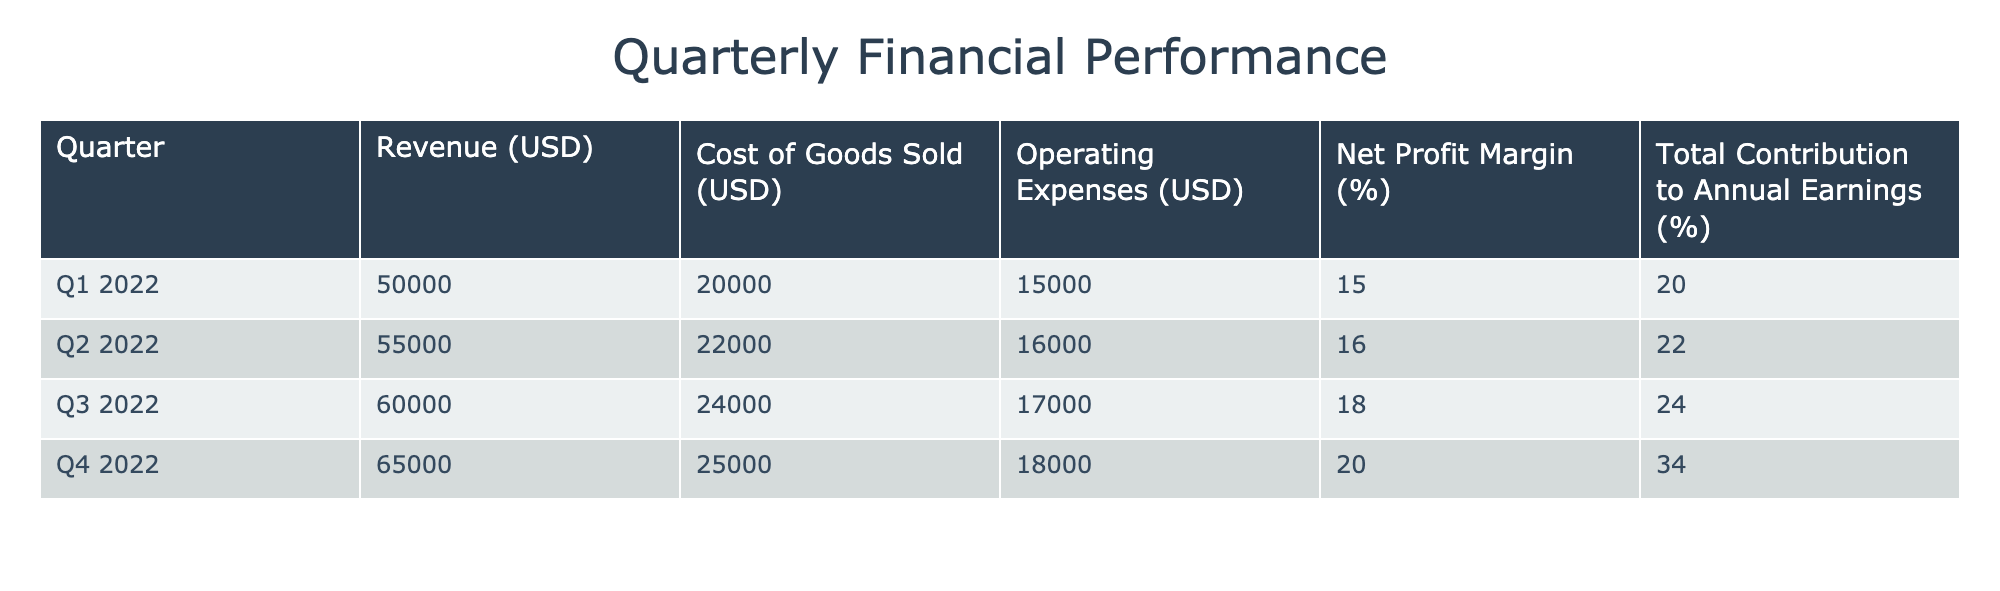What was the net profit margin for Q3 2022? The net profit margin for Q3 2022 is provided directly in the table under the 'Net Profit Margin (%)' column for that quarter. For Q3 2022, the percentage is 18%.
Answer: 18% Which quarter had the highest contribution to annual earnings? The table shows the 'Total Contribution to Annual Earnings (%)' for each quarter. The highest value among these is 34% for Q4 2022.
Answer: Q4 2022 What is the average revenue for the four quarters? To find the average revenue, sum the revenues for each quarter and divide by the number of quarters. The total revenue is 50000 + 55000 + 60000 + 65000 = 230000. Therefore, the average is 230000 / 4 = 57500.
Answer: 57500 True or False: The cost of goods sold in Q2 2022 was higher than in Q1 2022. By comparing the 'Cost of Goods Sold (USD)' values for Q2 2022 (22000) and Q1 2022 (20000), we see that 22000 is indeed greater than 20000. Thus, the statement is true.
Answer: True What was the increase in net profit margin from Q1 2022 to Q4 2022? The net profit margin for Q1 2022 is 15% and for Q4 2022 is 20%. The increase is calculated as the difference: 20% - 15% = 5%.
Answer: 5% Which quarter had the highest revenue, and what was that revenue? By reviewing the 'Revenue (USD)' column, Q4 2022 shows the highest value of 65000.
Answer: Q4 2022, 65000 Calculate the total operating expenses for all four quarters. To find total operating expenses, sum the values under the 'Operating Expenses (USD)' column: 15000 + 16000 + 17000 + 18000 = 66000.
Answer: 66000 How much more was the revenue in Q2 2022 compared to Q1 2022? The revenue for Q2 2022 is 55000 and for Q1 2022 it is 50000. The difference is 55000 - 50000 = 5000.
Answer: 5000 Which two quarters had a net profit margin of 16% or higher? Assessing the 'Net Profit Margin (%)' column, Q2 2022 (16%) and Q3 2022 (18%) both meet the condition of being 16% or higher. Hence, those two quarters are Q2 2022 and Q3 2022.
Answer: Q2 2022, Q3 2022 